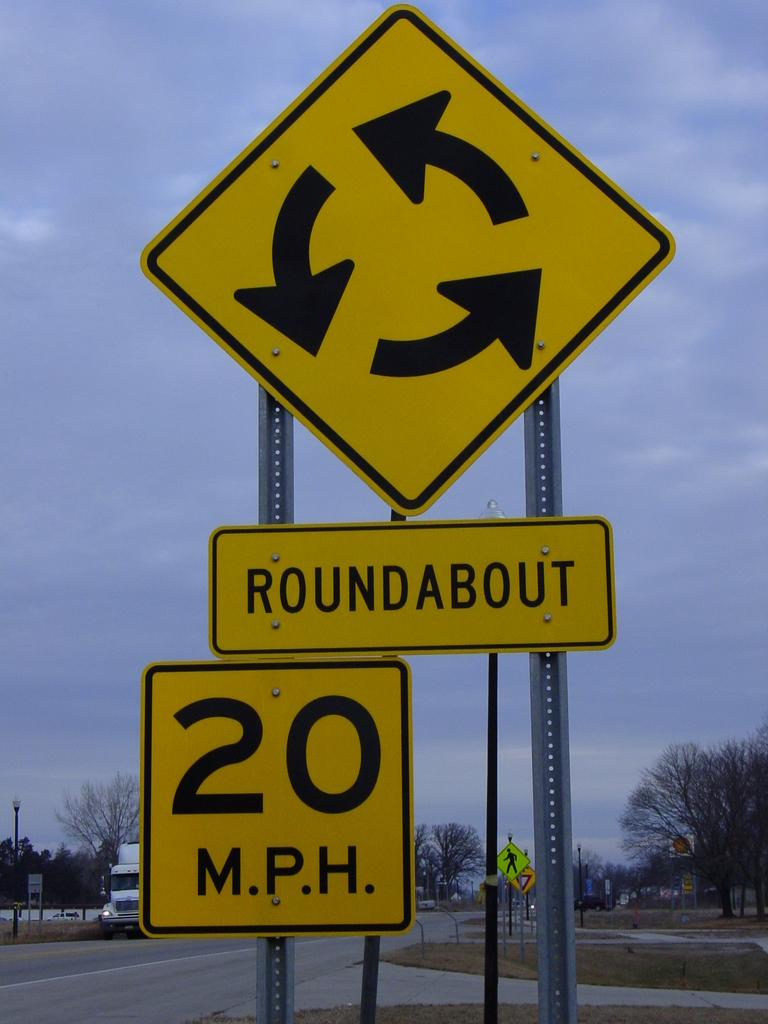<image>
Describe the image concisely. three yellow signs at a roundabout crosswalk with a speed limit of 20 mph 